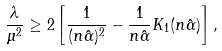<formula> <loc_0><loc_0><loc_500><loc_500>\frac { \lambda } { \mu ^ { 2 } } \geq 2 \left [ \frac { 1 } { ( n \hat { \alpha } ) ^ { 2 } } - \frac { 1 } { n \hat { \alpha } } K _ { 1 } ( n \hat { \alpha } ) \right ] ,</formula> 